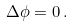<formula> <loc_0><loc_0><loc_500><loc_500>\Delta \phi = 0 \, .</formula> 